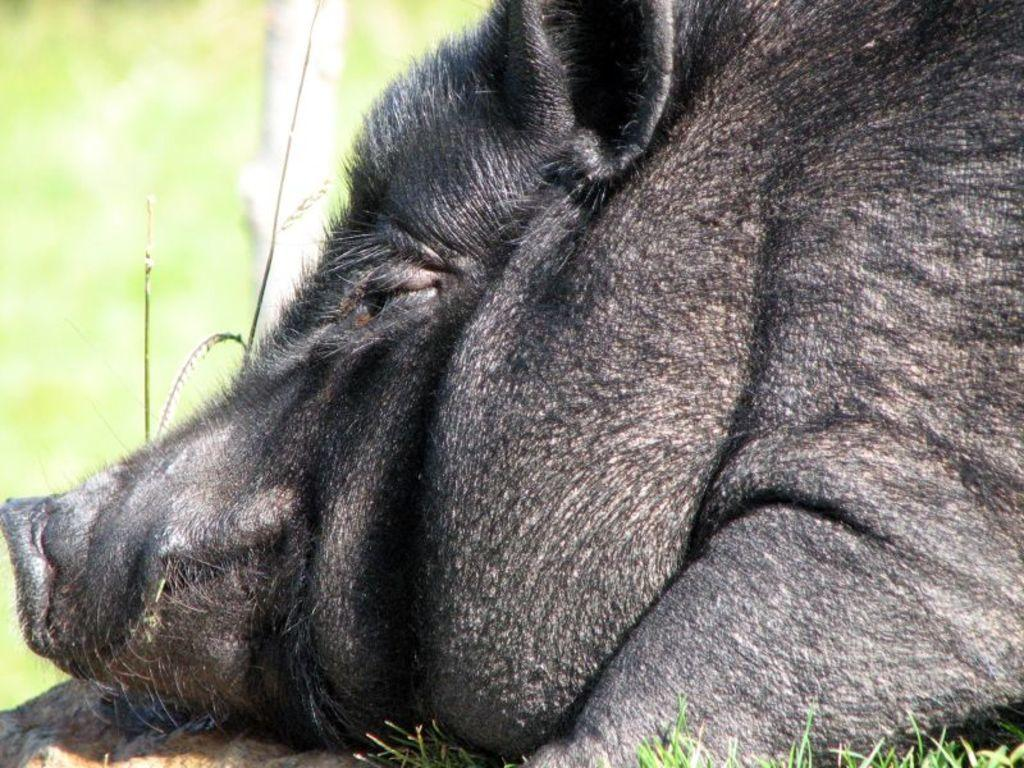What type of living organism can be seen in the image? There is an animal in the image. Can you describe the setting where the animal is located? The animal is on the grass. How many ants can be seen crawling on the animal in the image? There are no ants visible on the animal in the image. What type of beast is present in the image? The provided facts do not specify the type of animal, so it cannot be determined if it is a beast or not. 